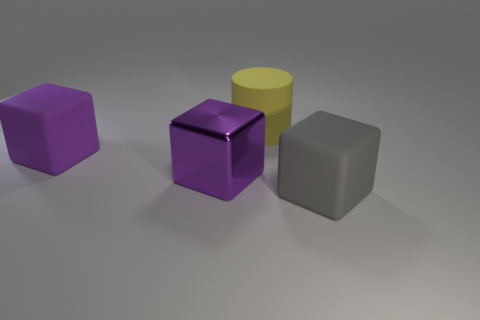Is the gray rubber block the same size as the purple matte block? Yes, the gray rubber block appears to be the same size as the purple matte block, with both exhibiting similar dimensions that suggest they are scaled to match each other in volume and proportion. 